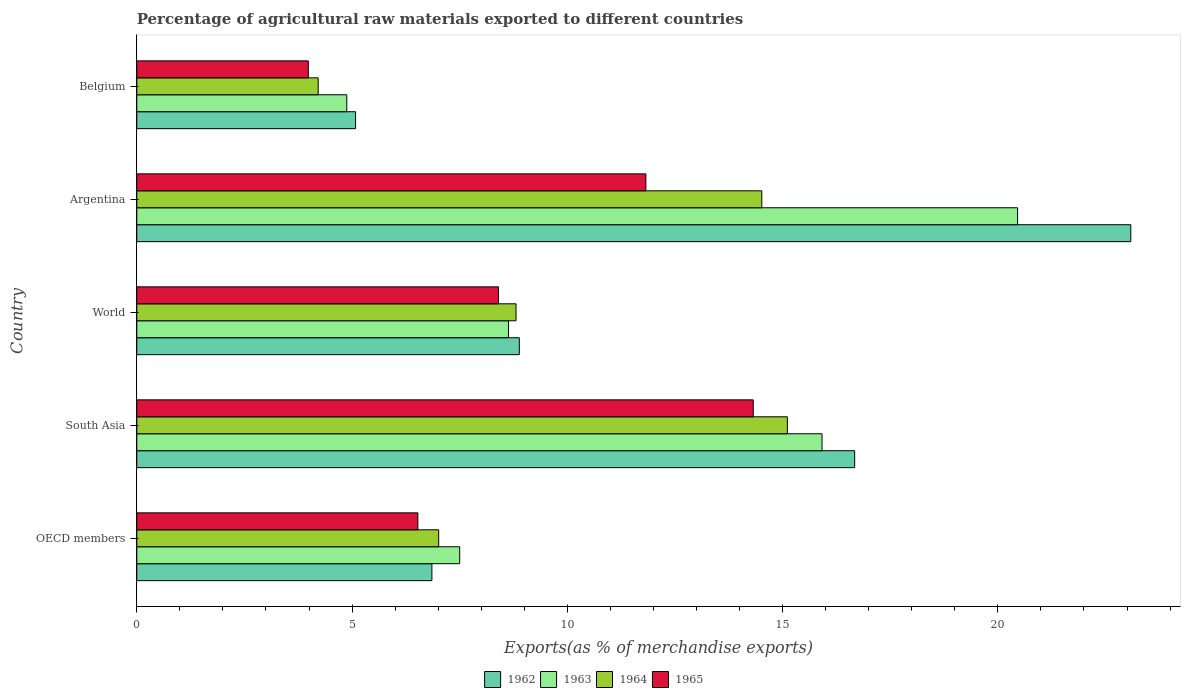How many different coloured bars are there?
Your answer should be very brief. 4. Are the number of bars per tick equal to the number of legend labels?
Offer a very short reply. Yes. How many bars are there on the 1st tick from the top?
Your answer should be compact. 4. In how many cases, is the number of bars for a given country not equal to the number of legend labels?
Give a very brief answer. 0. What is the percentage of exports to different countries in 1964 in Argentina?
Give a very brief answer. 14.52. Across all countries, what is the maximum percentage of exports to different countries in 1964?
Ensure brevity in your answer.  15.11. Across all countries, what is the minimum percentage of exports to different countries in 1962?
Provide a short and direct response. 5.08. In which country was the percentage of exports to different countries in 1964 maximum?
Give a very brief answer. South Asia. In which country was the percentage of exports to different countries in 1965 minimum?
Make the answer very short. Belgium. What is the total percentage of exports to different countries in 1965 in the graph?
Your answer should be compact. 45.06. What is the difference between the percentage of exports to different countries in 1962 in Belgium and that in World?
Make the answer very short. -3.8. What is the difference between the percentage of exports to different countries in 1962 in South Asia and the percentage of exports to different countries in 1963 in Argentina?
Provide a succinct answer. -3.78. What is the average percentage of exports to different countries in 1962 per country?
Your answer should be compact. 12.12. What is the difference between the percentage of exports to different countries in 1964 and percentage of exports to different countries in 1965 in Belgium?
Your response must be concise. 0.23. In how many countries, is the percentage of exports to different countries in 1963 greater than 8 %?
Your answer should be very brief. 3. What is the ratio of the percentage of exports to different countries in 1965 in OECD members to that in World?
Keep it short and to the point. 0.78. Is the percentage of exports to different countries in 1965 in Argentina less than that in South Asia?
Provide a succinct answer. Yes. What is the difference between the highest and the second highest percentage of exports to different countries in 1964?
Provide a succinct answer. 0.59. What is the difference between the highest and the lowest percentage of exports to different countries in 1964?
Your response must be concise. 10.9. In how many countries, is the percentage of exports to different countries in 1965 greater than the average percentage of exports to different countries in 1965 taken over all countries?
Your answer should be compact. 2. Is the sum of the percentage of exports to different countries in 1962 in Belgium and World greater than the maximum percentage of exports to different countries in 1964 across all countries?
Provide a succinct answer. No. Is it the case that in every country, the sum of the percentage of exports to different countries in 1964 and percentage of exports to different countries in 1962 is greater than the sum of percentage of exports to different countries in 1965 and percentage of exports to different countries in 1963?
Keep it short and to the point. No. What does the 3rd bar from the top in OECD members represents?
Give a very brief answer. 1963. What does the 4th bar from the bottom in Argentina represents?
Offer a very short reply. 1965. How many bars are there?
Provide a short and direct response. 20. Are all the bars in the graph horizontal?
Ensure brevity in your answer.  Yes. What is the difference between two consecutive major ticks on the X-axis?
Your response must be concise. 5. Does the graph contain any zero values?
Provide a succinct answer. No. Does the graph contain grids?
Keep it short and to the point. No. How many legend labels are there?
Give a very brief answer. 4. How are the legend labels stacked?
Your answer should be compact. Horizontal. What is the title of the graph?
Provide a short and direct response. Percentage of agricultural raw materials exported to different countries. Does "1977" appear as one of the legend labels in the graph?
Give a very brief answer. No. What is the label or title of the X-axis?
Your answer should be very brief. Exports(as % of merchandise exports). What is the Exports(as % of merchandise exports) in 1962 in OECD members?
Make the answer very short. 6.85. What is the Exports(as % of merchandise exports) of 1963 in OECD members?
Your answer should be compact. 7.5. What is the Exports(as % of merchandise exports) in 1964 in OECD members?
Your response must be concise. 7.01. What is the Exports(as % of merchandise exports) in 1965 in OECD members?
Ensure brevity in your answer.  6.53. What is the Exports(as % of merchandise exports) of 1962 in South Asia?
Provide a succinct answer. 16.67. What is the Exports(as % of merchandise exports) in 1963 in South Asia?
Your answer should be compact. 15.92. What is the Exports(as % of merchandise exports) of 1964 in South Asia?
Your answer should be very brief. 15.11. What is the Exports(as % of merchandise exports) in 1965 in South Asia?
Ensure brevity in your answer.  14.32. What is the Exports(as % of merchandise exports) in 1962 in World?
Provide a succinct answer. 8.89. What is the Exports(as % of merchandise exports) in 1963 in World?
Give a very brief answer. 8.63. What is the Exports(as % of merchandise exports) of 1964 in World?
Your answer should be compact. 8.81. What is the Exports(as % of merchandise exports) in 1965 in World?
Keep it short and to the point. 8.4. What is the Exports(as % of merchandise exports) of 1962 in Argentina?
Offer a very short reply. 23.09. What is the Exports(as % of merchandise exports) in 1963 in Argentina?
Provide a short and direct response. 20.46. What is the Exports(as % of merchandise exports) in 1964 in Argentina?
Offer a very short reply. 14.52. What is the Exports(as % of merchandise exports) of 1965 in Argentina?
Your answer should be compact. 11.82. What is the Exports(as % of merchandise exports) in 1962 in Belgium?
Provide a succinct answer. 5.08. What is the Exports(as % of merchandise exports) of 1963 in Belgium?
Offer a very short reply. 4.88. What is the Exports(as % of merchandise exports) in 1964 in Belgium?
Keep it short and to the point. 4.21. What is the Exports(as % of merchandise exports) in 1965 in Belgium?
Keep it short and to the point. 3.98. Across all countries, what is the maximum Exports(as % of merchandise exports) in 1962?
Ensure brevity in your answer.  23.09. Across all countries, what is the maximum Exports(as % of merchandise exports) in 1963?
Give a very brief answer. 20.46. Across all countries, what is the maximum Exports(as % of merchandise exports) in 1964?
Provide a succinct answer. 15.11. Across all countries, what is the maximum Exports(as % of merchandise exports) in 1965?
Your answer should be very brief. 14.32. Across all countries, what is the minimum Exports(as % of merchandise exports) in 1962?
Provide a succinct answer. 5.08. Across all countries, what is the minimum Exports(as % of merchandise exports) of 1963?
Ensure brevity in your answer.  4.88. Across all countries, what is the minimum Exports(as % of merchandise exports) of 1964?
Your response must be concise. 4.21. Across all countries, what is the minimum Exports(as % of merchandise exports) in 1965?
Your answer should be compact. 3.98. What is the total Exports(as % of merchandise exports) of 1962 in the graph?
Offer a terse response. 60.59. What is the total Exports(as % of merchandise exports) in 1963 in the graph?
Provide a short and direct response. 57.39. What is the total Exports(as % of merchandise exports) of 1964 in the graph?
Make the answer very short. 49.66. What is the total Exports(as % of merchandise exports) in 1965 in the graph?
Provide a short and direct response. 45.06. What is the difference between the Exports(as % of merchandise exports) in 1962 in OECD members and that in South Asia?
Provide a short and direct response. -9.82. What is the difference between the Exports(as % of merchandise exports) of 1963 in OECD members and that in South Asia?
Provide a succinct answer. -8.42. What is the difference between the Exports(as % of merchandise exports) in 1964 in OECD members and that in South Asia?
Provide a succinct answer. -8.1. What is the difference between the Exports(as % of merchandise exports) in 1965 in OECD members and that in South Asia?
Your response must be concise. -7.79. What is the difference between the Exports(as % of merchandise exports) in 1962 in OECD members and that in World?
Provide a succinct answer. -2.03. What is the difference between the Exports(as % of merchandise exports) in 1963 in OECD members and that in World?
Your answer should be very brief. -1.13. What is the difference between the Exports(as % of merchandise exports) of 1964 in OECD members and that in World?
Your answer should be very brief. -1.8. What is the difference between the Exports(as % of merchandise exports) of 1965 in OECD members and that in World?
Give a very brief answer. -1.87. What is the difference between the Exports(as % of merchandise exports) of 1962 in OECD members and that in Argentina?
Offer a very short reply. -16.23. What is the difference between the Exports(as % of merchandise exports) in 1963 in OECD members and that in Argentina?
Provide a succinct answer. -12.96. What is the difference between the Exports(as % of merchandise exports) of 1964 in OECD members and that in Argentina?
Provide a short and direct response. -7.5. What is the difference between the Exports(as % of merchandise exports) of 1965 in OECD members and that in Argentina?
Give a very brief answer. -5.3. What is the difference between the Exports(as % of merchandise exports) of 1962 in OECD members and that in Belgium?
Provide a succinct answer. 1.77. What is the difference between the Exports(as % of merchandise exports) of 1963 in OECD members and that in Belgium?
Your answer should be very brief. 2.62. What is the difference between the Exports(as % of merchandise exports) in 1964 in OECD members and that in Belgium?
Your answer should be compact. 2.8. What is the difference between the Exports(as % of merchandise exports) of 1965 in OECD members and that in Belgium?
Provide a short and direct response. 2.54. What is the difference between the Exports(as % of merchandise exports) in 1962 in South Asia and that in World?
Your answer should be compact. 7.79. What is the difference between the Exports(as % of merchandise exports) in 1963 in South Asia and that in World?
Offer a very short reply. 7.28. What is the difference between the Exports(as % of merchandise exports) of 1964 in South Asia and that in World?
Offer a very short reply. 6.3. What is the difference between the Exports(as % of merchandise exports) of 1965 in South Asia and that in World?
Offer a very short reply. 5.92. What is the difference between the Exports(as % of merchandise exports) of 1962 in South Asia and that in Argentina?
Provide a short and direct response. -6.41. What is the difference between the Exports(as % of merchandise exports) in 1963 in South Asia and that in Argentina?
Provide a succinct answer. -4.54. What is the difference between the Exports(as % of merchandise exports) in 1964 in South Asia and that in Argentina?
Keep it short and to the point. 0.59. What is the difference between the Exports(as % of merchandise exports) in 1965 in South Asia and that in Argentina?
Your answer should be compact. 2.49. What is the difference between the Exports(as % of merchandise exports) in 1962 in South Asia and that in Belgium?
Make the answer very short. 11.59. What is the difference between the Exports(as % of merchandise exports) of 1963 in South Asia and that in Belgium?
Your answer should be very brief. 11.04. What is the difference between the Exports(as % of merchandise exports) of 1964 in South Asia and that in Belgium?
Your answer should be very brief. 10.9. What is the difference between the Exports(as % of merchandise exports) in 1965 in South Asia and that in Belgium?
Provide a short and direct response. 10.34. What is the difference between the Exports(as % of merchandise exports) of 1962 in World and that in Argentina?
Give a very brief answer. -14.2. What is the difference between the Exports(as % of merchandise exports) in 1963 in World and that in Argentina?
Keep it short and to the point. -11.83. What is the difference between the Exports(as % of merchandise exports) in 1964 in World and that in Argentina?
Your answer should be very brief. -5.71. What is the difference between the Exports(as % of merchandise exports) in 1965 in World and that in Argentina?
Ensure brevity in your answer.  -3.42. What is the difference between the Exports(as % of merchandise exports) in 1962 in World and that in Belgium?
Ensure brevity in your answer.  3.8. What is the difference between the Exports(as % of merchandise exports) in 1963 in World and that in Belgium?
Offer a terse response. 3.76. What is the difference between the Exports(as % of merchandise exports) in 1964 in World and that in Belgium?
Your answer should be very brief. 4.6. What is the difference between the Exports(as % of merchandise exports) in 1965 in World and that in Belgium?
Offer a very short reply. 4.42. What is the difference between the Exports(as % of merchandise exports) of 1962 in Argentina and that in Belgium?
Provide a short and direct response. 18.01. What is the difference between the Exports(as % of merchandise exports) of 1963 in Argentina and that in Belgium?
Provide a short and direct response. 15.58. What is the difference between the Exports(as % of merchandise exports) in 1964 in Argentina and that in Belgium?
Keep it short and to the point. 10.3. What is the difference between the Exports(as % of merchandise exports) in 1965 in Argentina and that in Belgium?
Offer a terse response. 7.84. What is the difference between the Exports(as % of merchandise exports) of 1962 in OECD members and the Exports(as % of merchandise exports) of 1963 in South Asia?
Offer a very short reply. -9.06. What is the difference between the Exports(as % of merchandise exports) of 1962 in OECD members and the Exports(as % of merchandise exports) of 1964 in South Asia?
Your answer should be compact. -8.26. What is the difference between the Exports(as % of merchandise exports) in 1962 in OECD members and the Exports(as % of merchandise exports) in 1965 in South Asia?
Ensure brevity in your answer.  -7.46. What is the difference between the Exports(as % of merchandise exports) of 1963 in OECD members and the Exports(as % of merchandise exports) of 1964 in South Asia?
Provide a succinct answer. -7.61. What is the difference between the Exports(as % of merchandise exports) in 1963 in OECD members and the Exports(as % of merchandise exports) in 1965 in South Asia?
Keep it short and to the point. -6.82. What is the difference between the Exports(as % of merchandise exports) in 1964 in OECD members and the Exports(as % of merchandise exports) in 1965 in South Asia?
Provide a short and direct response. -7.31. What is the difference between the Exports(as % of merchandise exports) in 1962 in OECD members and the Exports(as % of merchandise exports) in 1963 in World?
Provide a short and direct response. -1.78. What is the difference between the Exports(as % of merchandise exports) of 1962 in OECD members and the Exports(as % of merchandise exports) of 1964 in World?
Make the answer very short. -1.95. What is the difference between the Exports(as % of merchandise exports) in 1962 in OECD members and the Exports(as % of merchandise exports) in 1965 in World?
Offer a very short reply. -1.55. What is the difference between the Exports(as % of merchandise exports) of 1963 in OECD members and the Exports(as % of merchandise exports) of 1964 in World?
Provide a succinct answer. -1.31. What is the difference between the Exports(as % of merchandise exports) in 1963 in OECD members and the Exports(as % of merchandise exports) in 1965 in World?
Offer a terse response. -0.9. What is the difference between the Exports(as % of merchandise exports) of 1964 in OECD members and the Exports(as % of merchandise exports) of 1965 in World?
Provide a short and direct response. -1.39. What is the difference between the Exports(as % of merchandise exports) of 1962 in OECD members and the Exports(as % of merchandise exports) of 1963 in Argentina?
Provide a succinct answer. -13.6. What is the difference between the Exports(as % of merchandise exports) in 1962 in OECD members and the Exports(as % of merchandise exports) in 1964 in Argentina?
Make the answer very short. -7.66. What is the difference between the Exports(as % of merchandise exports) of 1962 in OECD members and the Exports(as % of merchandise exports) of 1965 in Argentina?
Your answer should be compact. -4.97. What is the difference between the Exports(as % of merchandise exports) of 1963 in OECD members and the Exports(as % of merchandise exports) of 1964 in Argentina?
Offer a very short reply. -7.02. What is the difference between the Exports(as % of merchandise exports) of 1963 in OECD members and the Exports(as % of merchandise exports) of 1965 in Argentina?
Give a very brief answer. -4.32. What is the difference between the Exports(as % of merchandise exports) of 1964 in OECD members and the Exports(as % of merchandise exports) of 1965 in Argentina?
Keep it short and to the point. -4.81. What is the difference between the Exports(as % of merchandise exports) in 1962 in OECD members and the Exports(as % of merchandise exports) in 1963 in Belgium?
Your answer should be compact. 1.98. What is the difference between the Exports(as % of merchandise exports) of 1962 in OECD members and the Exports(as % of merchandise exports) of 1964 in Belgium?
Ensure brevity in your answer.  2.64. What is the difference between the Exports(as % of merchandise exports) in 1962 in OECD members and the Exports(as % of merchandise exports) in 1965 in Belgium?
Provide a short and direct response. 2.87. What is the difference between the Exports(as % of merchandise exports) in 1963 in OECD members and the Exports(as % of merchandise exports) in 1964 in Belgium?
Provide a short and direct response. 3.29. What is the difference between the Exports(as % of merchandise exports) of 1963 in OECD members and the Exports(as % of merchandise exports) of 1965 in Belgium?
Provide a succinct answer. 3.52. What is the difference between the Exports(as % of merchandise exports) of 1964 in OECD members and the Exports(as % of merchandise exports) of 1965 in Belgium?
Keep it short and to the point. 3.03. What is the difference between the Exports(as % of merchandise exports) of 1962 in South Asia and the Exports(as % of merchandise exports) of 1963 in World?
Provide a succinct answer. 8.04. What is the difference between the Exports(as % of merchandise exports) in 1962 in South Asia and the Exports(as % of merchandise exports) in 1964 in World?
Your answer should be very brief. 7.87. What is the difference between the Exports(as % of merchandise exports) in 1962 in South Asia and the Exports(as % of merchandise exports) in 1965 in World?
Provide a succinct answer. 8.27. What is the difference between the Exports(as % of merchandise exports) of 1963 in South Asia and the Exports(as % of merchandise exports) of 1964 in World?
Ensure brevity in your answer.  7.11. What is the difference between the Exports(as % of merchandise exports) of 1963 in South Asia and the Exports(as % of merchandise exports) of 1965 in World?
Offer a terse response. 7.52. What is the difference between the Exports(as % of merchandise exports) of 1964 in South Asia and the Exports(as % of merchandise exports) of 1965 in World?
Make the answer very short. 6.71. What is the difference between the Exports(as % of merchandise exports) in 1962 in South Asia and the Exports(as % of merchandise exports) in 1963 in Argentina?
Your answer should be very brief. -3.78. What is the difference between the Exports(as % of merchandise exports) in 1962 in South Asia and the Exports(as % of merchandise exports) in 1964 in Argentina?
Your answer should be very brief. 2.16. What is the difference between the Exports(as % of merchandise exports) of 1962 in South Asia and the Exports(as % of merchandise exports) of 1965 in Argentina?
Your answer should be very brief. 4.85. What is the difference between the Exports(as % of merchandise exports) in 1963 in South Asia and the Exports(as % of merchandise exports) in 1964 in Argentina?
Provide a short and direct response. 1.4. What is the difference between the Exports(as % of merchandise exports) of 1963 in South Asia and the Exports(as % of merchandise exports) of 1965 in Argentina?
Ensure brevity in your answer.  4.09. What is the difference between the Exports(as % of merchandise exports) of 1964 in South Asia and the Exports(as % of merchandise exports) of 1965 in Argentina?
Your answer should be compact. 3.29. What is the difference between the Exports(as % of merchandise exports) in 1962 in South Asia and the Exports(as % of merchandise exports) in 1963 in Belgium?
Make the answer very short. 11.8. What is the difference between the Exports(as % of merchandise exports) of 1962 in South Asia and the Exports(as % of merchandise exports) of 1964 in Belgium?
Your answer should be compact. 12.46. What is the difference between the Exports(as % of merchandise exports) of 1962 in South Asia and the Exports(as % of merchandise exports) of 1965 in Belgium?
Offer a very short reply. 12.69. What is the difference between the Exports(as % of merchandise exports) of 1963 in South Asia and the Exports(as % of merchandise exports) of 1964 in Belgium?
Ensure brevity in your answer.  11.7. What is the difference between the Exports(as % of merchandise exports) of 1963 in South Asia and the Exports(as % of merchandise exports) of 1965 in Belgium?
Provide a short and direct response. 11.93. What is the difference between the Exports(as % of merchandise exports) in 1964 in South Asia and the Exports(as % of merchandise exports) in 1965 in Belgium?
Keep it short and to the point. 11.13. What is the difference between the Exports(as % of merchandise exports) in 1962 in World and the Exports(as % of merchandise exports) in 1963 in Argentina?
Ensure brevity in your answer.  -11.57. What is the difference between the Exports(as % of merchandise exports) of 1962 in World and the Exports(as % of merchandise exports) of 1964 in Argentina?
Your answer should be very brief. -5.63. What is the difference between the Exports(as % of merchandise exports) in 1962 in World and the Exports(as % of merchandise exports) in 1965 in Argentina?
Offer a terse response. -2.94. What is the difference between the Exports(as % of merchandise exports) in 1963 in World and the Exports(as % of merchandise exports) in 1964 in Argentina?
Provide a short and direct response. -5.88. What is the difference between the Exports(as % of merchandise exports) of 1963 in World and the Exports(as % of merchandise exports) of 1965 in Argentina?
Provide a short and direct response. -3.19. What is the difference between the Exports(as % of merchandise exports) of 1964 in World and the Exports(as % of merchandise exports) of 1965 in Argentina?
Keep it short and to the point. -3.02. What is the difference between the Exports(as % of merchandise exports) in 1962 in World and the Exports(as % of merchandise exports) in 1963 in Belgium?
Ensure brevity in your answer.  4.01. What is the difference between the Exports(as % of merchandise exports) in 1962 in World and the Exports(as % of merchandise exports) in 1964 in Belgium?
Provide a succinct answer. 4.67. What is the difference between the Exports(as % of merchandise exports) of 1962 in World and the Exports(as % of merchandise exports) of 1965 in Belgium?
Offer a terse response. 4.9. What is the difference between the Exports(as % of merchandise exports) in 1963 in World and the Exports(as % of merchandise exports) in 1964 in Belgium?
Ensure brevity in your answer.  4.42. What is the difference between the Exports(as % of merchandise exports) in 1963 in World and the Exports(as % of merchandise exports) in 1965 in Belgium?
Offer a very short reply. 4.65. What is the difference between the Exports(as % of merchandise exports) of 1964 in World and the Exports(as % of merchandise exports) of 1965 in Belgium?
Your response must be concise. 4.82. What is the difference between the Exports(as % of merchandise exports) in 1962 in Argentina and the Exports(as % of merchandise exports) in 1963 in Belgium?
Give a very brief answer. 18.21. What is the difference between the Exports(as % of merchandise exports) in 1962 in Argentina and the Exports(as % of merchandise exports) in 1964 in Belgium?
Your response must be concise. 18.87. What is the difference between the Exports(as % of merchandise exports) of 1962 in Argentina and the Exports(as % of merchandise exports) of 1965 in Belgium?
Your response must be concise. 19.1. What is the difference between the Exports(as % of merchandise exports) of 1963 in Argentina and the Exports(as % of merchandise exports) of 1964 in Belgium?
Your answer should be compact. 16.25. What is the difference between the Exports(as % of merchandise exports) of 1963 in Argentina and the Exports(as % of merchandise exports) of 1965 in Belgium?
Provide a short and direct response. 16.48. What is the difference between the Exports(as % of merchandise exports) of 1964 in Argentina and the Exports(as % of merchandise exports) of 1965 in Belgium?
Ensure brevity in your answer.  10.53. What is the average Exports(as % of merchandise exports) of 1962 per country?
Provide a succinct answer. 12.12. What is the average Exports(as % of merchandise exports) of 1963 per country?
Your response must be concise. 11.48. What is the average Exports(as % of merchandise exports) of 1964 per country?
Offer a very short reply. 9.93. What is the average Exports(as % of merchandise exports) in 1965 per country?
Make the answer very short. 9.01. What is the difference between the Exports(as % of merchandise exports) of 1962 and Exports(as % of merchandise exports) of 1963 in OECD members?
Keep it short and to the point. -0.65. What is the difference between the Exports(as % of merchandise exports) in 1962 and Exports(as % of merchandise exports) in 1964 in OECD members?
Your answer should be very brief. -0.16. What is the difference between the Exports(as % of merchandise exports) of 1962 and Exports(as % of merchandise exports) of 1965 in OECD members?
Provide a short and direct response. 0.33. What is the difference between the Exports(as % of merchandise exports) in 1963 and Exports(as % of merchandise exports) in 1964 in OECD members?
Your answer should be compact. 0.49. What is the difference between the Exports(as % of merchandise exports) of 1963 and Exports(as % of merchandise exports) of 1965 in OECD members?
Keep it short and to the point. 0.97. What is the difference between the Exports(as % of merchandise exports) in 1964 and Exports(as % of merchandise exports) in 1965 in OECD members?
Your answer should be compact. 0.48. What is the difference between the Exports(as % of merchandise exports) of 1962 and Exports(as % of merchandise exports) of 1963 in South Asia?
Provide a succinct answer. 0.76. What is the difference between the Exports(as % of merchandise exports) in 1962 and Exports(as % of merchandise exports) in 1964 in South Asia?
Your answer should be very brief. 1.56. What is the difference between the Exports(as % of merchandise exports) in 1962 and Exports(as % of merchandise exports) in 1965 in South Asia?
Ensure brevity in your answer.  2.36. What is the difference between the Exports(as % of merchandise exports) of 1963 and Exports(as % of merchandise exports) of 1964 in South Asia?
Provide a short and direct response. 0.81. What is the difference between the Exports(as % of merchandise exports) of 1963 and Exports(as % of merchandise exports) of 1965 in South Asia?
Your response must be concise. 1.6. What is the difference between the Exports(as % of merchandise exports) of 1964 and Exports(as % of merchandise exports) of 1965 in South Asia?
Offer a very short reply. 0.79. What is the difference between the Exports(as % of merchandise exports) in 1962 and Exports(as % of merchandise exports) in 1963 in World?
Provide a short and direct response. 0.25. What is the difference between the Exports(as % of merchandise exports) in 1962 and Exports(as % of merchandise exports) in 1964 in World?
Give a very brief answer. 0.08. What is the difference between the Exports(as % of merchandise exports) in 1962 and Exports(as % of merchandise exports) in 1965 in World?
Keep it short and to the point. 0.48. What is the difference between the Exports(as % of merchandise exports) in 1963 and Exports(as % of merchandise exports) in 1964 in World?
Your answer should be compact. -0.18. What is the difference between the Exports(as % of merchandise exports) of 1963 and Exports(as % of merchandise exports) of 1965 in World?
Your answer should be very brief. 0.23. What is the difference between the Exports(as % of merchandise exports) of 1964 and Exports(as % of merchandise exports) of 1965 in World?
Make the answer very short. 0.41. What is the difference between the Exports(as % of merchandise exports) in 1962 and Exports(as % of merchandise exports) in 1963 in Argentina?
Provide a short and direct response. 2.63. What is the difference between the Exports(as % of merchandise exports) in 1962 and Exports(as % of merchandise exports) in 1964 in Argentina?
Your response must be concise. 8.57. What is the difference between the Exports(as % of merchandise exports) in 1962 and Exports(as % of merchandise exports) in 1965 in Argentina?
Your response must be concise. 11.26. What is the difference between the Exports(as % of merchandise exports) in 1963 and Exports(as % of merchandise exports) in 1964 in Argentina?
Make the answer very short. 5.94. What is the difference between the Exports(as % of merchandise exports) in 1963 and Exports(as % of merchandise exports) in 1965 in Argentina?
Give a very brief answer. 8.63. What is the difference between the Exports(as % of merchandise exports) in 1964 and Exports(as % of merchandise exports) in 1965 in Argentina?
Provide a short and direct response. 2.69. What is the difference between the Exports(as % of merchandise exports) of 1962 and Exports(as % of merchandise exports) of 1963 in Belgium?
Offer a terse response. 0.2. What is the difference between the Exports(as % of merchandise exports) in 1962 and Exports(as % of merchandise exports) in 1964 in Belgium?
Offer a very short reply. 0.87. What is the difference between the Exports(as % of merchandise exports) in 1962 and Exports(as % of merchandise exports) in 1965 in Belgium?
Your answer should be compact. 1.1. What is the difference between the Exports(as % of merchandise exports) of 1963 and Exports(as % of merchandise exports) of 1964 in Belgium?
Your response must be concise. 0.66. What is the difference between the Exports(as % of merchandise exports) of 1963 and Exports(as % of merchandise exports) of 1965 in Belgium?
Offer a very short reply. 0.89. What is the difference between the Exports(as % of merchandise exports) of 1964 and Exports(as % of merchandise exports) of 1965 in Belgium?
Offer a terse response. 0.23. What is the ratio of the Exports(as % of merchandise exports) in 1962 in OECD members to that in South Asia?
Ensure brevity in your answer.  0.41. What is the ratio of the Exports(as % of merchandise exports) of 1963 in OECD members to that in South Asia?
Ensure brevity in your answer.  0.47. What is the ratio of the Exports(as % of merchandise exports) of 1964 in OECD members to that in South Asia?
Keep it short and to the point. 0.46. What is the ratio of the Exports(as % of merchandise exports) in 1965 in OECD members to that in South Asia?
Provide a succinct answer. 0.46. What is the ratio of the Exports(as % of merchandise exports) in 1962 in OECD members to that in World?
Your response must be concise. 0.77. What is the ratio of the Exports(as % of merchandise exports) of 1963 in OECD members to that in World?
Provide a short and direct response. 0.87. What is the ratio of the Exports(as % of merchandise exports) of 1964 in OECD members to that in World?
Ensure brevity in your answer.  0.8. What is the ratio of the Exports(as % of merchandise exports) of 1965 in OECD members to that in World?
Make the answer very short. 0.78. What is the ratio of the Exports(as % of merchandise exports) in 1962 in OECD members to that in Argentina?
Your response must be concise. 0.3. What is the ratio of the Exports(as % of merchandise exports) of 1963 in OECD members to that in Argentina?
Offer a very short reply. 0.37. What is the ratio of the Exports(as % of merchandise exports) in 1964 in OECD members to that in Argentina?
Offer a very short reply. 0.48. What is the ratio of the Exports(as % of merchandise exports) of 1965 in OECD members to that in Argentina?
Your answer should be compact. 0.55. What is the ratio of the Exports(as % of merchandise exports) of 1962 in OECD members to that in Belgium?
Your answer should be compact. 1.35. What is the ratio of the Exports(as % of merchandise exports) of 1963 in OECD members to that in Belgium?
Your answer should be very brief. 1.54. What is the ratio of the Exports(as % of merchandise exports) in 1964 in OECD members to that in Belgium?
Your answer should be compact. 1.66. What is the ratio of the Exports(as % of merchandise exports) of 1965 in OECD members to that in Belgium?
Offer a very short reply. 1.64. What is the ratio of the Exports(as % of merchandise exports) in 1962 in South Asia to that in World?
Your response must be concise. 1.88. What is the ratio of the Exports(as % of merchandise exports) of 1963 in South Asia to that in World?
Your answer should be compact. 1.84. What is the ratio of the Exports(as % of merchandise exports) of 1964 in South Asia to that in World?
Your response must be concise. 1.72. What is the ratio of the Exports(as % of merchandise exports) of 1965 in South Asia to that in World?
Provide a succinct answer. 1.7. What is the ratio of the Exports(as % of merchandise exports) of 1962 in South Asia to that in Argentina?
Offer a very short reply. 0.72. What is the ratio of the Exports(as % of merchandise exports) in 1963 in South Asia to that in Argentina?
Your response must be concise. 0.78. What is the ratio of the Exports(as % of merchandise exports) in 1964 in South Asia to that in Argentina?
Ensure brevity in your answer.  1.04. What is the ratio of the Exports(as % of merchandise exports) in 1965 in South Asia to that in Argentina?
Keep it short and to the point. 1.21. What is the ratio of the Exports(as % of merchandise exports) in 1962 in South Asia to that in Belgium?
Provide a short and direct response. 3.28. What is the ratio of the Exports(as % of merchandise exports) in 1963 in South Asia to that in Belgium?
Give a very brief answer. 3.26. What is the ratio of the Exports(as % of merchandise exports) in 1964 in South Asia to that in Belgium?
Ensure brevity in your answer.  3.59. What is the ratio of the Exports(as % of merchandise exports) of 1965 in South Asia to that in Belgium?
Your answer should be compact. 3.59. What is the ratio of the Exports(as % of merchandise exports) in 1962 in World to that in Argentina?
Provide a short and direct response. 0.38. What is the ratio of the Exports(as % of merchandise exports) of 1963 in World to that in Argentina?
Your answer should be compact. 0.42. What is the ratio of the Exports(as % of merchandise exports) in 1964 in World to that in Argentina?
Make the answer very short. 0.61. What is the ratio of the Exports(as % of merchandise exports) of 1965 in World to that in Argentina?
Provide a succinct answer. 0.71. What is the ratio of the Exports(as % of merchandise exports) in 1962 in World to that in Belgium?
Keep it short and to the point. 1.75. What is the ratio of the Exports(as % of merchandise exports) of 1963 in World to that in Belgium?
Your answer should be compact. 1.77. What is the ratio of the Exports(as % of merchandise exports) of 1964 in World to that in Belgium?
Your answer should be compact. 2.09. What is the ratio of the Exports(as % of merchandise exports) of 1965 in World to that in Belgium?
Keep it short and to the point. 2.11. What is the ratio of the Exports(as % of merchandise exports) of 1962 in Argentina to that in Belgium?
Ensure brevity in your answer.  4.54. What is the ratio of the Exports(as % of merchandise exports) in 1963 in Argentina to that in Belgium?
Keep it short and to the point. 4.19. What is the ratio of the Exports(as % of merchandise exports) in 1964 in Argentina to that in Belgium?
Provide a short and direct response. 3.45. What is the ratio of the Exports(as % of merchandise exports) in 1965 in Argentina to that in Belgium?
Provide a succinct answer. 2.97. What is the difference between the highest and the second highest Exports(as % of merchandise exports) of 1962?
Provide a succinct answer. 6.41. What is the difference between the highest and the second highest Exports(as % of merchandise exports) in 1963?
Make the answer very short. 4.54. What is the difference between the highest and the second highest Exports(as % of merchandise exports) in 1964?
Give a very brief answer. 0.59. What is the difference between the highest and the second highest Exports(as % of merchandise exports) in 1965?
Keep it short and to the point. 2.49. What is the difference between the highest and the lowest Exports(as % of merchandise exports) in 1962?
Your answer should be compact. 18.01. What is the difference between the highest and the lowest Exports(as % of merchandise exports) in 1963?
Make the answer very short. 15.58. What is the difference between the highest and the lowest Exports(as % of merchandise exports) in 1964?
Offer a very short reply. 10.9. What is the difference between the highest and the lowest Exports(as % of merchandise exports) of 1965?
Provide a succinct answer. 10.34. 